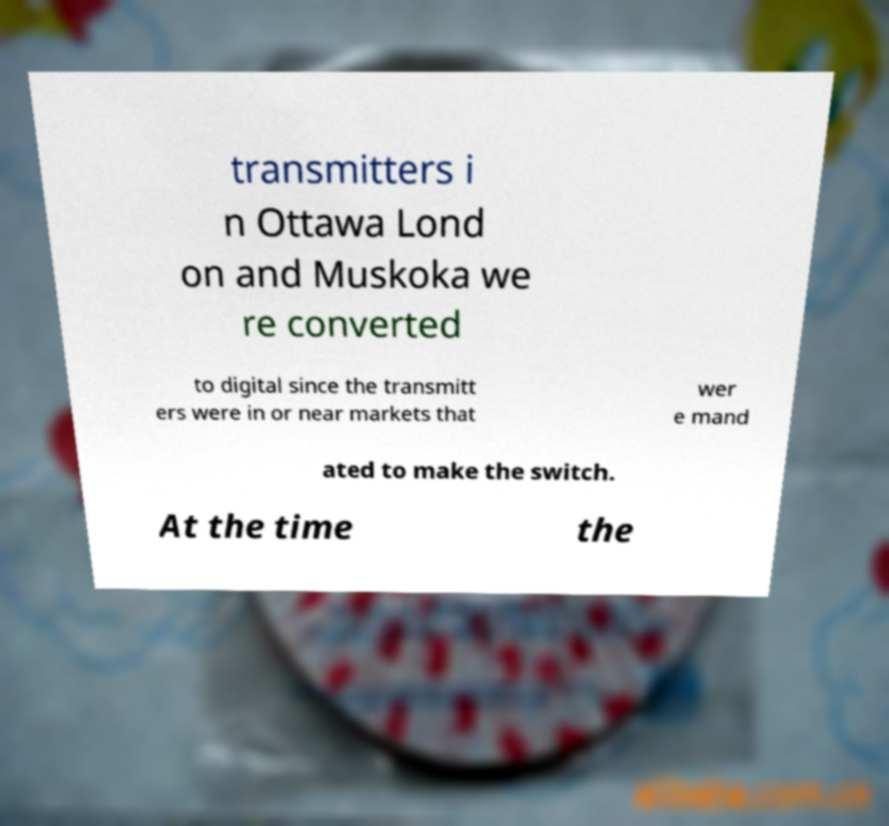Could you assist in decoding the text presented in this image and type it out clearly? transmitters i n Ottawa Lond on and Muskoka we re converted to digital since the transmitt ers were in or near markets that wer e mand ated to make the switch. At the time the 